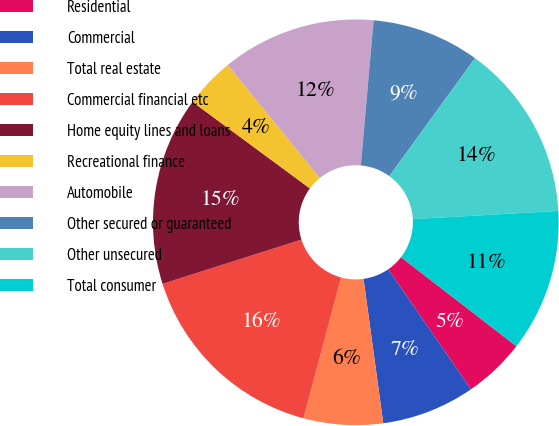Convert chart to OTSL. <chart><loc_0><loc_0><loc_500><loc_500><pie_chart><fcel>Residential<fcel>Commercial<fcel>Total real estate<fcel>Commercial financial etc<fcel>Home equity lines and loans<fcel>Recreational finance<fcel>Automobile<fcel>Other secured or guaranteed<fcel>Other unsecured<fcel>Total consumer<nl><fcel>4.93%<fcel>7.45%<fcel>6.31%<fcel>15.94%<fcel>15.02%<fcel>4.01%<fcel>12.27%<fcel>8.6%<fcel>14.11%<fcel>11.35%<nl></chart> 